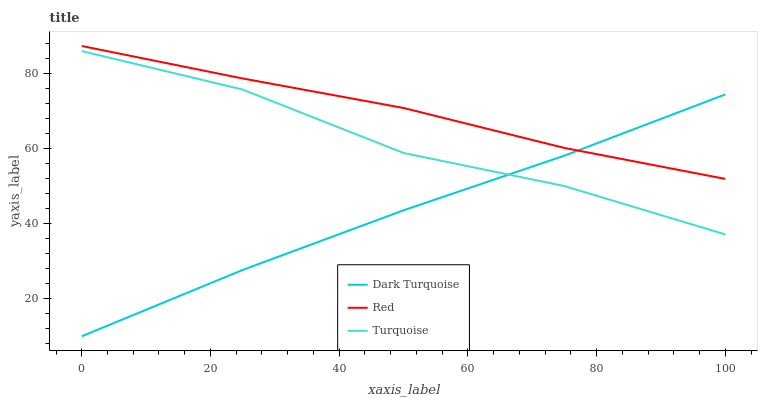Does Dark Turquoise have the minimum area under the curve?
Answer yes or no. Yes. Does Red have the maximum area under the curve?
Answer yes or no. Yes. Does Turquoise have the minimum area under the curve?
Answer yes or no. No. Does Turquoise have the maximum area under the curve?
Answer yes or no. No. Is Dark Turquoise the smoothest?
Answer yes or no. Yes. Is Turquoise the roughest?
Answer yes or no. Yes. Is Red the smoothest?
Answer yes or no. No. Is Red the roughest?
Answer yes or no. No. Does Dark Turquoise have the lowest value?
Answer yes or no. Yes. Does Turquoise have the lowest value?
Answer yes or no. No. Does Red have the highest value?
Answer yes or no. Yes. Does Turquoise have the highest value?
Answer yes or no. No. Is Turquoise less than Red?
Answer yes or no. Yes. Is Red greater than Turquoise?
Answer yes or no. Yes. Does Red intersect Dark Turquoise?
Answer yes or no. Yes. Is Red less than Dark Turquoise?
Answer yes or no. No. Is Red greater than Dark Turquoise?
Answer yes or no. No. Does Turquoise intersect Red?
Answer yes or no. No. 